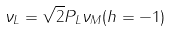Convert formula to latex. <formula><loc_0><loc_0><loc_500><loc_500>\nu _ { L } = \sqrt { 2 } P _ { L } \nu _ { M } ( h = - 1 )</formula> 